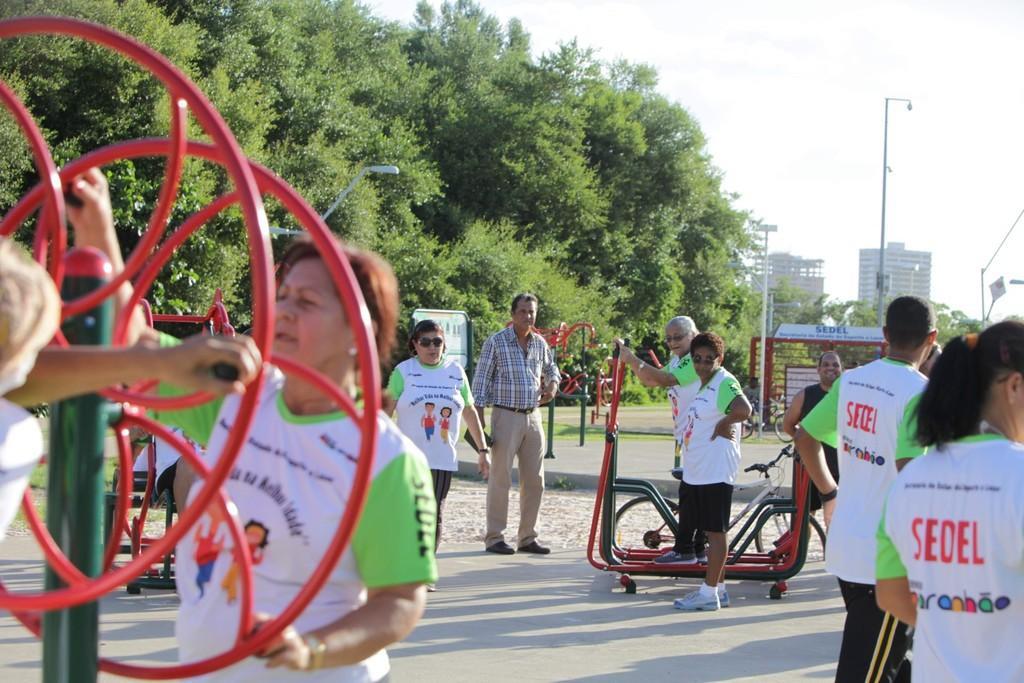Describe this image in one or two sentences. In this image we can see a few people and bicycles, also we can see some playing objects, there are some buildings, trees, poles, lights and the sky. 